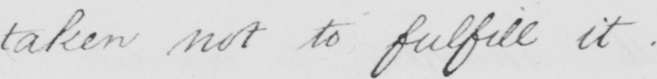Please transcribe the handwritten text in this image. taken not to fulfill it . 